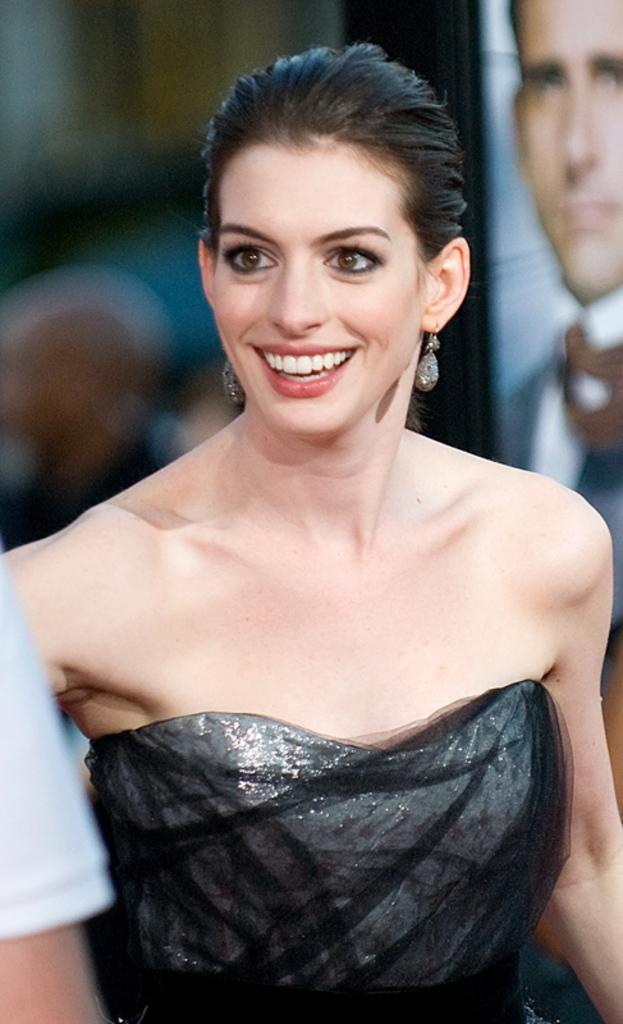Could you give a brief overview of what you see in this image? In the center of the image we can see a lady standing and smiling. She is wearing a black dress. On the right we can see a board. 